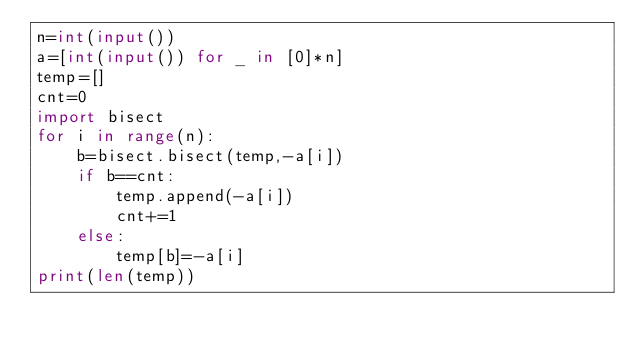Convert code to text. <code><loc_0><loc_0><loc_500><loc_500><_Python_>n=int(input())
a=[int(input()) for _ in [0]*n]
temp=[]
cnt=0
import bisect
for i in range(n):
    b=bisect.bisect(temp,-a[i])
    if b==cnt:
        temp.append(-a[i])
        cnt+=1
    else:
        temp[b]=-a[i]
print(len(temp))</code> 